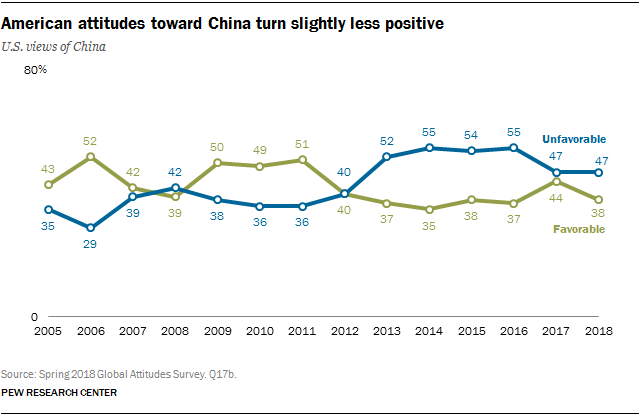Give some essential details in this illustration. The value of green graph is lowest in the year 2014. In 2017, the sum of all values is greater than the sum of all values in 2005. 